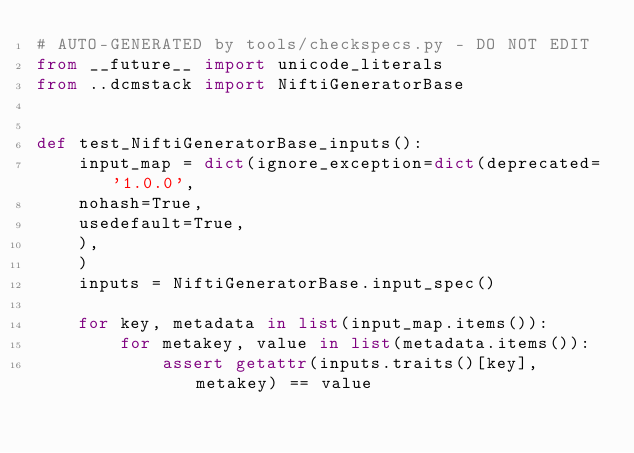<code> <loc_0><loc_0><loc_500><loc_500><_Python_># AUTO-GENERATED by tools/checkspecs.py - DO NOT EDIT
from __future__ import unicode_literals
from ..dcmstack import NiftiGeneratorBase


def test_NiftiGeneratorBase_inputs():
    input_map = dict(ignore_exception=dict(deprecated='1.0.0',
    nohash=True,
    usedefault=True,
    ),
    )
    inputs = NiftiGeneratorBase.input_spec()

    for key, metadata in list(input_map.items()):
        for metakey, value in list(metadata.items()):
            assert getattr(inputs.traits()[key], metakey) == value

</code> 